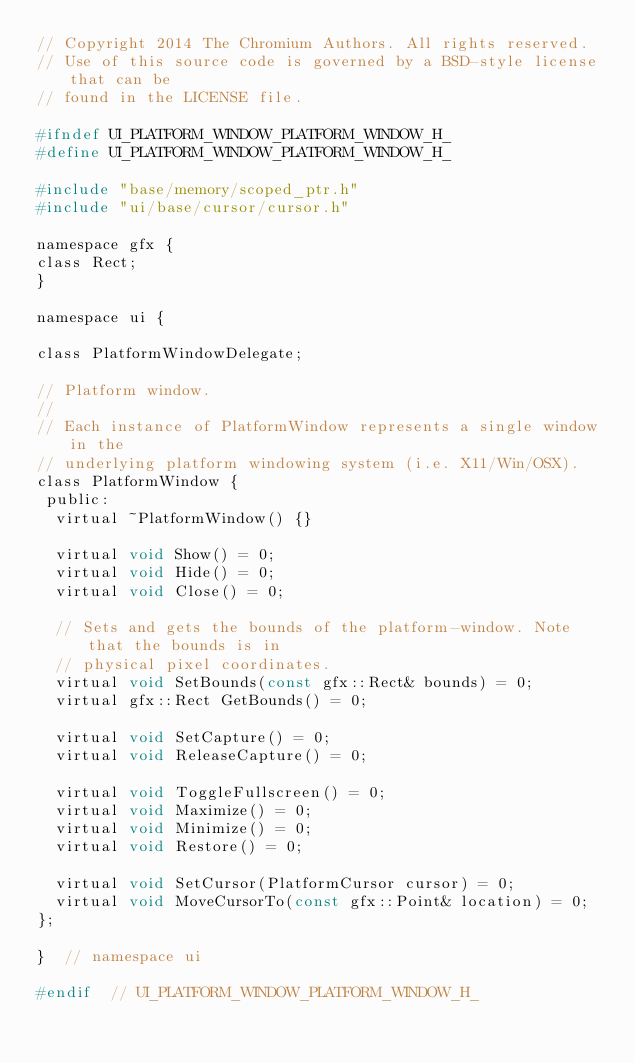Convert code to text. <code><loc_0><loc_0><loc_500><loc_500><_C_>// Copyright 2014 The Chromium Authors. All rights reserved.
// Use of this source code is governed by a BSD-style license that can be
// found in the LICENSE file.

#ifndef UI_PLATFORM_WINDOW_PLATFORM_WINDOW_H_
#define UI_PLATFORM_WINDOW_PLATFORM_WINDOW_H_

#include "base/memory/scoped_ptr.h"
#include "ui/base/cursor/cursor.h"

namespace gfx {
class Rect;
}

namespace ui {

class PlatformWindowDelegate;

// Platform window.
//
// Each instance of PlatformWindow represents a single window in the
// underlying platform windowing system (i.e. X11/Win/OSX).
class PlatformWindow {
 public:
  virtual ~PlatformWindow() {}

  virtual void Show() = 0;
  virtual void Hide() = 0;
  virtual void Close() = 0;

  // Sets and gets the bounds of the platform-window. Note that the bounds is in
  // physical pixel coordinates.
  virtual void SetBounds(const gfx::Rect& bounds) = 0;
  virtual gfx::Rect GetBounds() = 0;

  virtual void SetCapture() = 0;
  virtual void ReleaseCapture() = 0;

  virtual void ToggleFullscreen() = 0;
  virtual void Maximize() = 0;
  virtual void Minimize() = 0;
  virtual void Restore() = 0;

  virtual void SetCursor(PlatformCursor cursor) = 0;
  virtual void MoveCursorTo(const gfx::Point& location) = 0;
};

}  // namespace ui

#endif  // UI_PLATFORM_WINDOW_PLATFORM_WINDOW_H_
</code> 